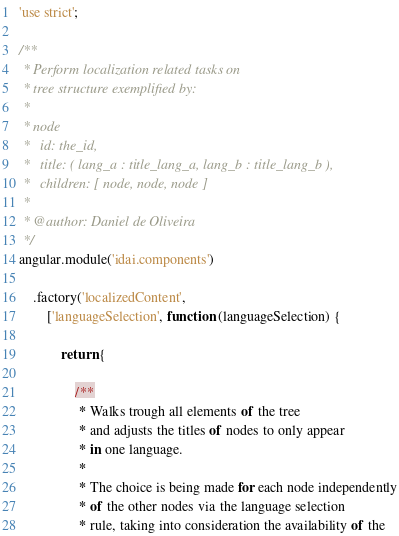<code> <loc_0><loc_0><loc_500><loc_500><_JavaScript_>'use strict';

/**
 * Perform localization related tasks on
 * tree structure exemplified by:
 *
 * node
 *   id: the_id,
 *   title: ( lang_a : title_lang_a, lang_b : title_lang_b ),
 *   children: [ node, node, node ]
 *
 * @author: Daniel de Oliveira
 */
angular.module('idai.components')

    .factory('localizedContent',
        ['languageSelection', function (languageSelection) {

            return {

                /**
                 * Walks trough all elements of the tree
                 * and adjusts the titles of nodes to only appear
                 * in one language.
                 *
                 * The choice is being made for each node independently
                 * of the other nodes via the language selection
                 * rule, taking into consideration the availability of the</code> 